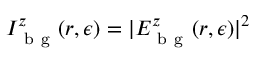Convert formula to latex. <formula><loc_0><loc_0><loc_500><loc_500>I _ { b g } ^ { z } ( r , \epsilon ) = | E _ { b g } ^ { z } ( r , \epsilon ) | ^ { 2 }</formula> 